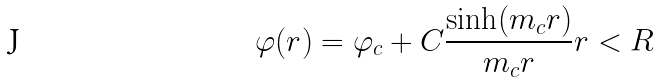<formula> <loc_0><loc_0><loc_500><loc_500>\varphi ( r ) = \varphi _ { c } + C \frac { \sinh ( m _ { c } r ) } { m _ { c } r } r < R</formula> 